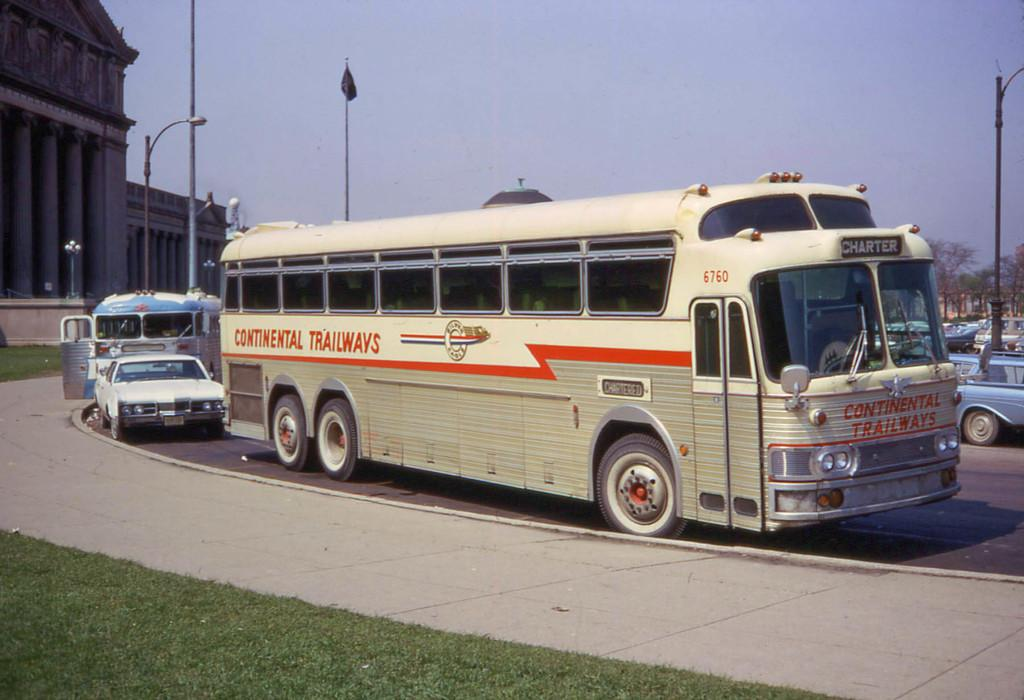What is the main subject of the image? The main subject of the image is a bus. What is the bus doing in the image? The bus is moving on the road. What can be seen on the left side of the image? There are monuments on the left side of the image. What is visible at the top of the image? The sky is visible at the top of the image. How many insects can be seen crawling on the bus in the image? There are no insects visible on the bus in the image. What type of grip does the bus have on the road in the image? The image does not provide information about the type of grip the bus has on the road. 